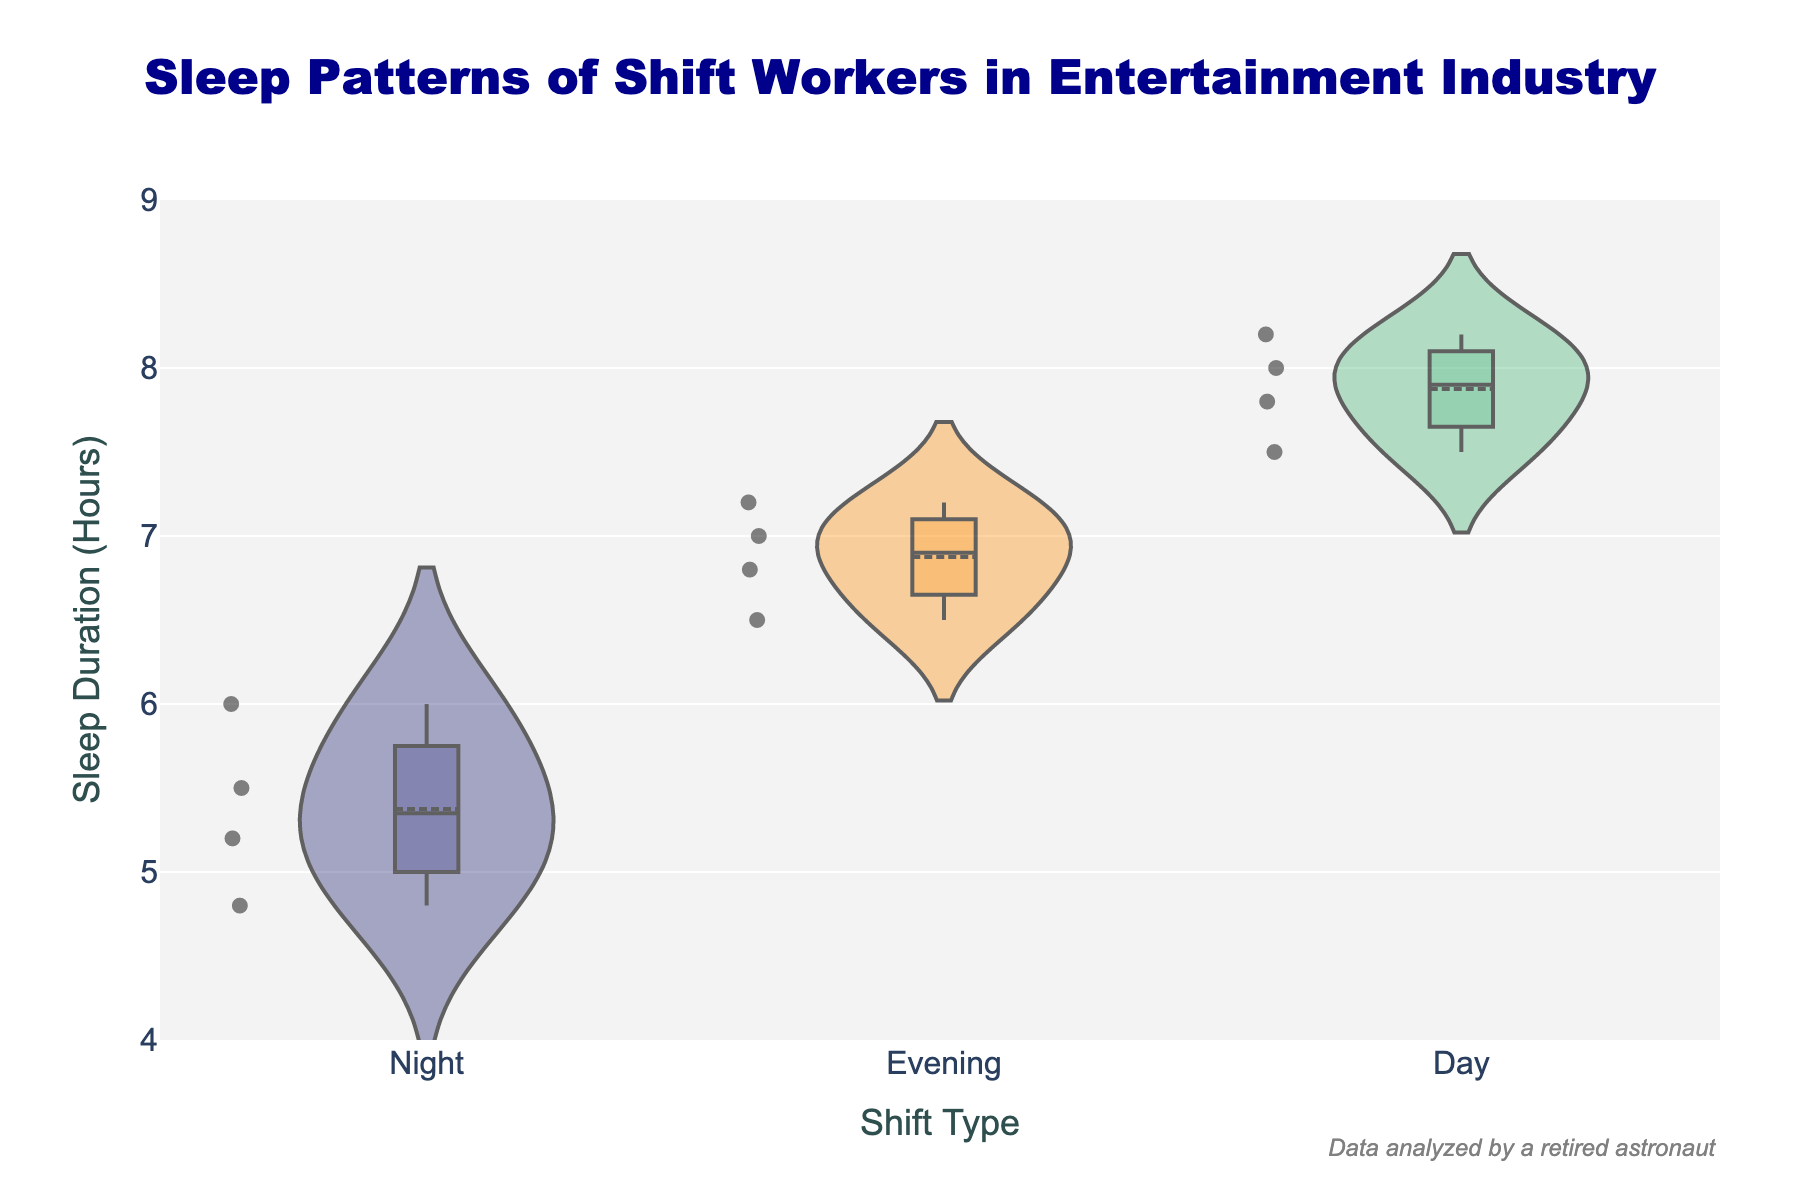What's the title of the figure? The title of the figure is displayed prominently at the top in a larger font size compared to other text elements.
Answer: Sleep Patterns of Shift Workers in Entertainment Industry What are the shift types compared in the figure? The shift types are displayed along the x-axis, and each one has a corresponding violin plot.
Answer: Night, Evening, Day Which shift type has the widest range of sleep durations? To determine the widest range, look for the violin plot that extends the furthest vertically.
Answer: Day Which shift type shows the highest median sleep duration? The median is indicated by the white line inside each violin plot.
Answer: Day What is the lowest sleep duration recorded and which shift type does it belong to? Identify the lowest point on the y-axis corresponding to any violin plot.
Answer: Night, 4.8 hours Compare the average sleep duration between the Night and Evening shift types. The average sleep duration can be inferred from the position of the horizontal line within each violin plot. Compare the positions of these lines for Night and Evening.
Answer: Night < Evening What is the range of sleep durations for the Evening shift type? Identify the lowest and highest points on the violin plot for the Evening shift.
Answer: 6.5 to 7.2 hours How many data points are there for the Day shift type? The number of data points is shown by the individual points within each violin plot for the Day shift.
Answer: 4 Does any shift type have overlapping sleep durations with another shift type? Look for areas where different violin plots extend into the same range on the y-axis.
Answer: Yes, all shift types overlap What can you infer about the sleep patterns of shift workers in the entertainment industry from the figure? Summarize the trends and distributions visible in the violin plots for all three shift types.
Answer: Night shift workers sleep the least, Day shift workers sleep the most, and there is variability in sleep duration for all shifts 